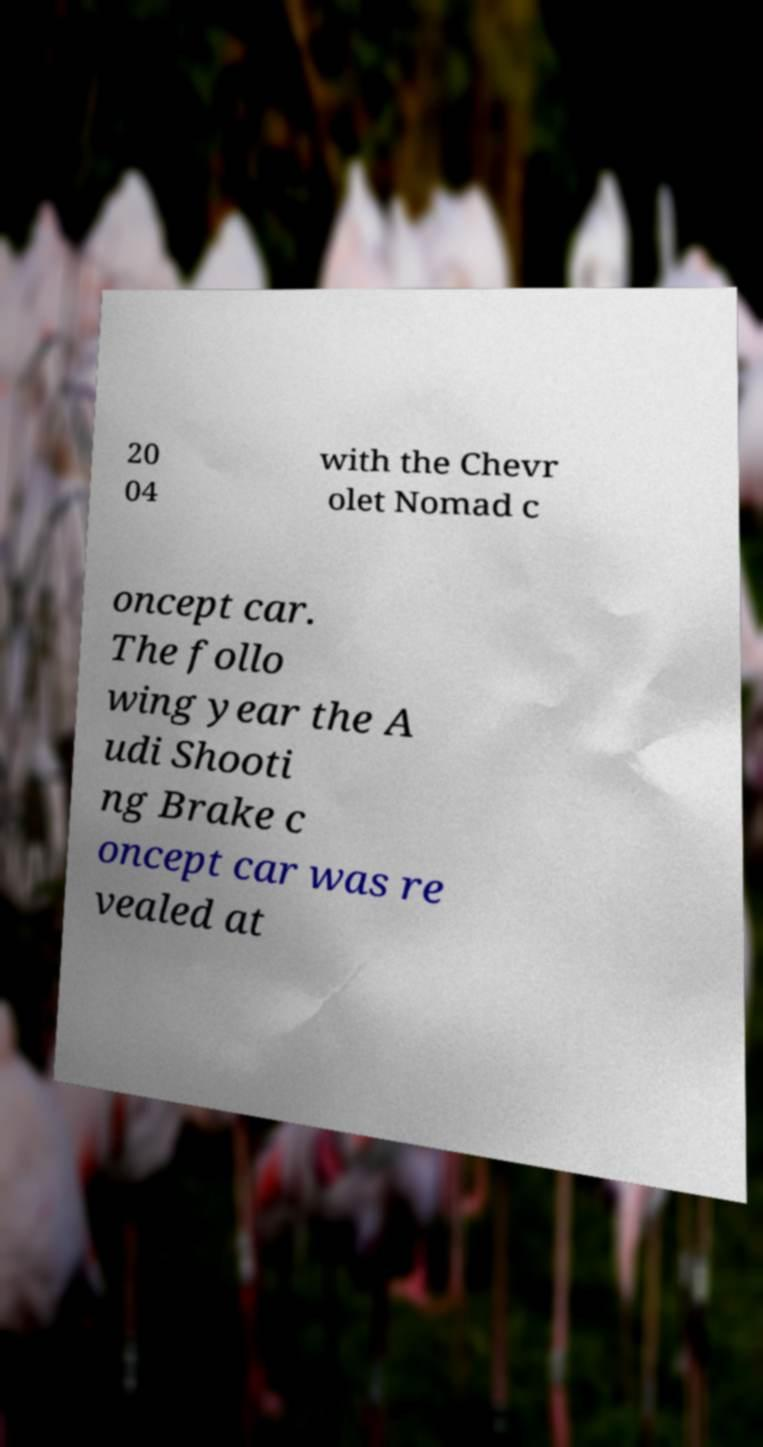What messages or text are displayed in this image? I need them in a readable, typed format. 20 04 with the Chevr olet Nomad c oncept car. The follo wing year the A udi Shooti ng Brake c oncept car was re vealed at 